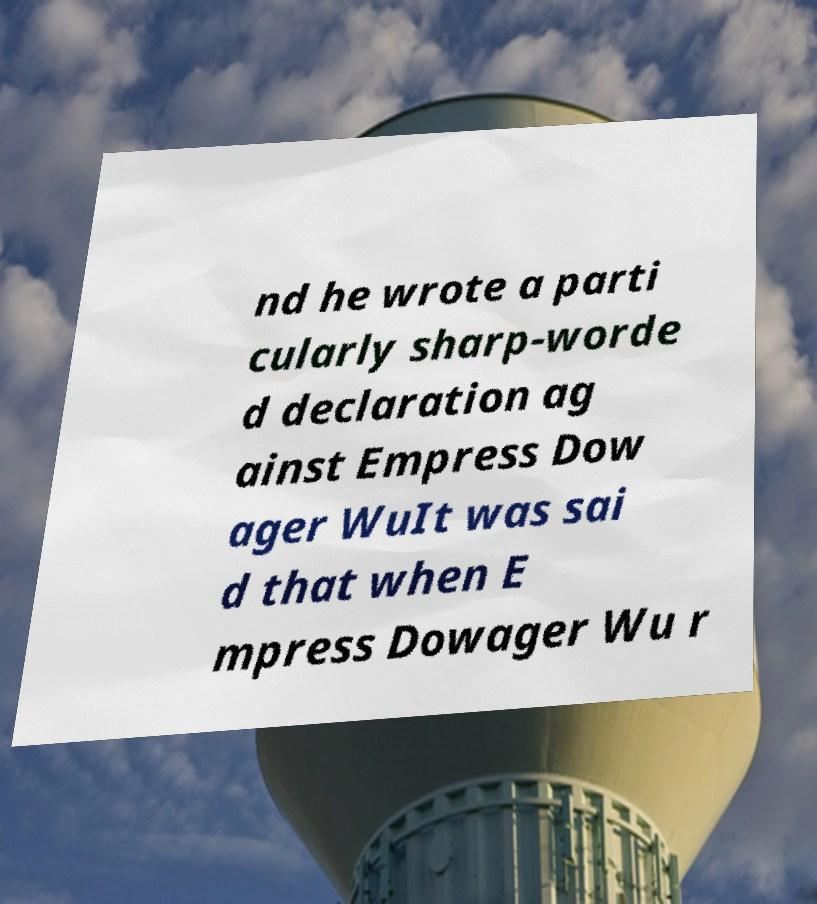There's text embedded in this image that I need extracted. Can you transcribe it verbatim? nd he wrote a parti cularly sharp-worde d declaration ag ainst Empress Dow ager WuIt was sai d that when E mpress Dowager Wu r 